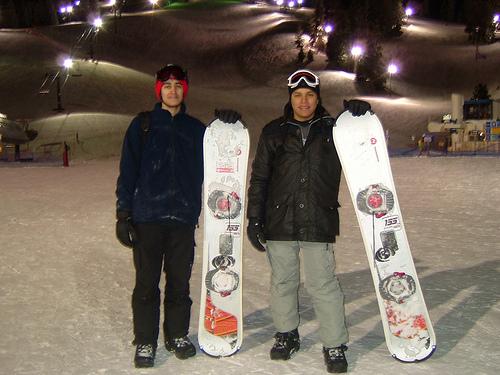There are lights in the scene?
Short answer required. Yes. What do the men have in their left hands?
Answer briefly. Snowboards. What do the men have on their foreheads?
Quick response, please. Goggles. 